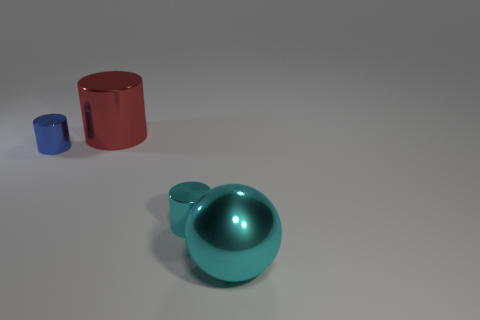How many other things are made of the same material as the big red thing?
Your answer should be very brief. 3. Is there any other thing that has the same size as the cyan shiny cylinder?
Provide a succinct answer. Yes. Is the number of small blue things greater than the number of large purple things?
Your answer should be compact. Yes. How big is the thing behind the object on the left side of the big metallic thing behind the tiny blue metal object?
Keep it short and to the point. Large. Do the blue shiny thing and the shiny cylinder on the right side of the large red metal cylinder have the same size?
Offer a terse response. Yes. Is the number of large cyan metal balls that are behind the big cyan shiny sphere less than the number of tiny brown matte cylinders?
Your answer should be compact. No. How many metal cylinders have the same color as the shiny sphere?
Give a very brief answer. 1. Are there fewer large purple metal cylinders than things?
Your answer should be compact. Yes. Is the material of the sphere the same as the small cyan thing?
Ensure brevity in your answer.  Yes. What color is the sphere that is right of the cyan object that is to the left of the large cyan ball?
Make the answer very short. Cyan. 